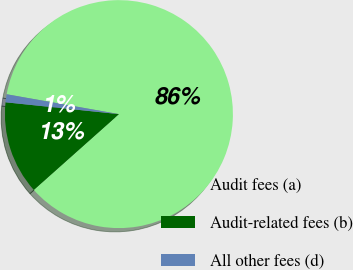Convert chart. <chart><loc_0><loc_0><loc_500><loc_500><pie_chart><fcel>Audit fees (a)<fcel>Audit-related fees (b)<fcel>All other fees (d)<nl><fcel>85.64%<fcel>13.23%<fcel>1.13%<nl></chart> 